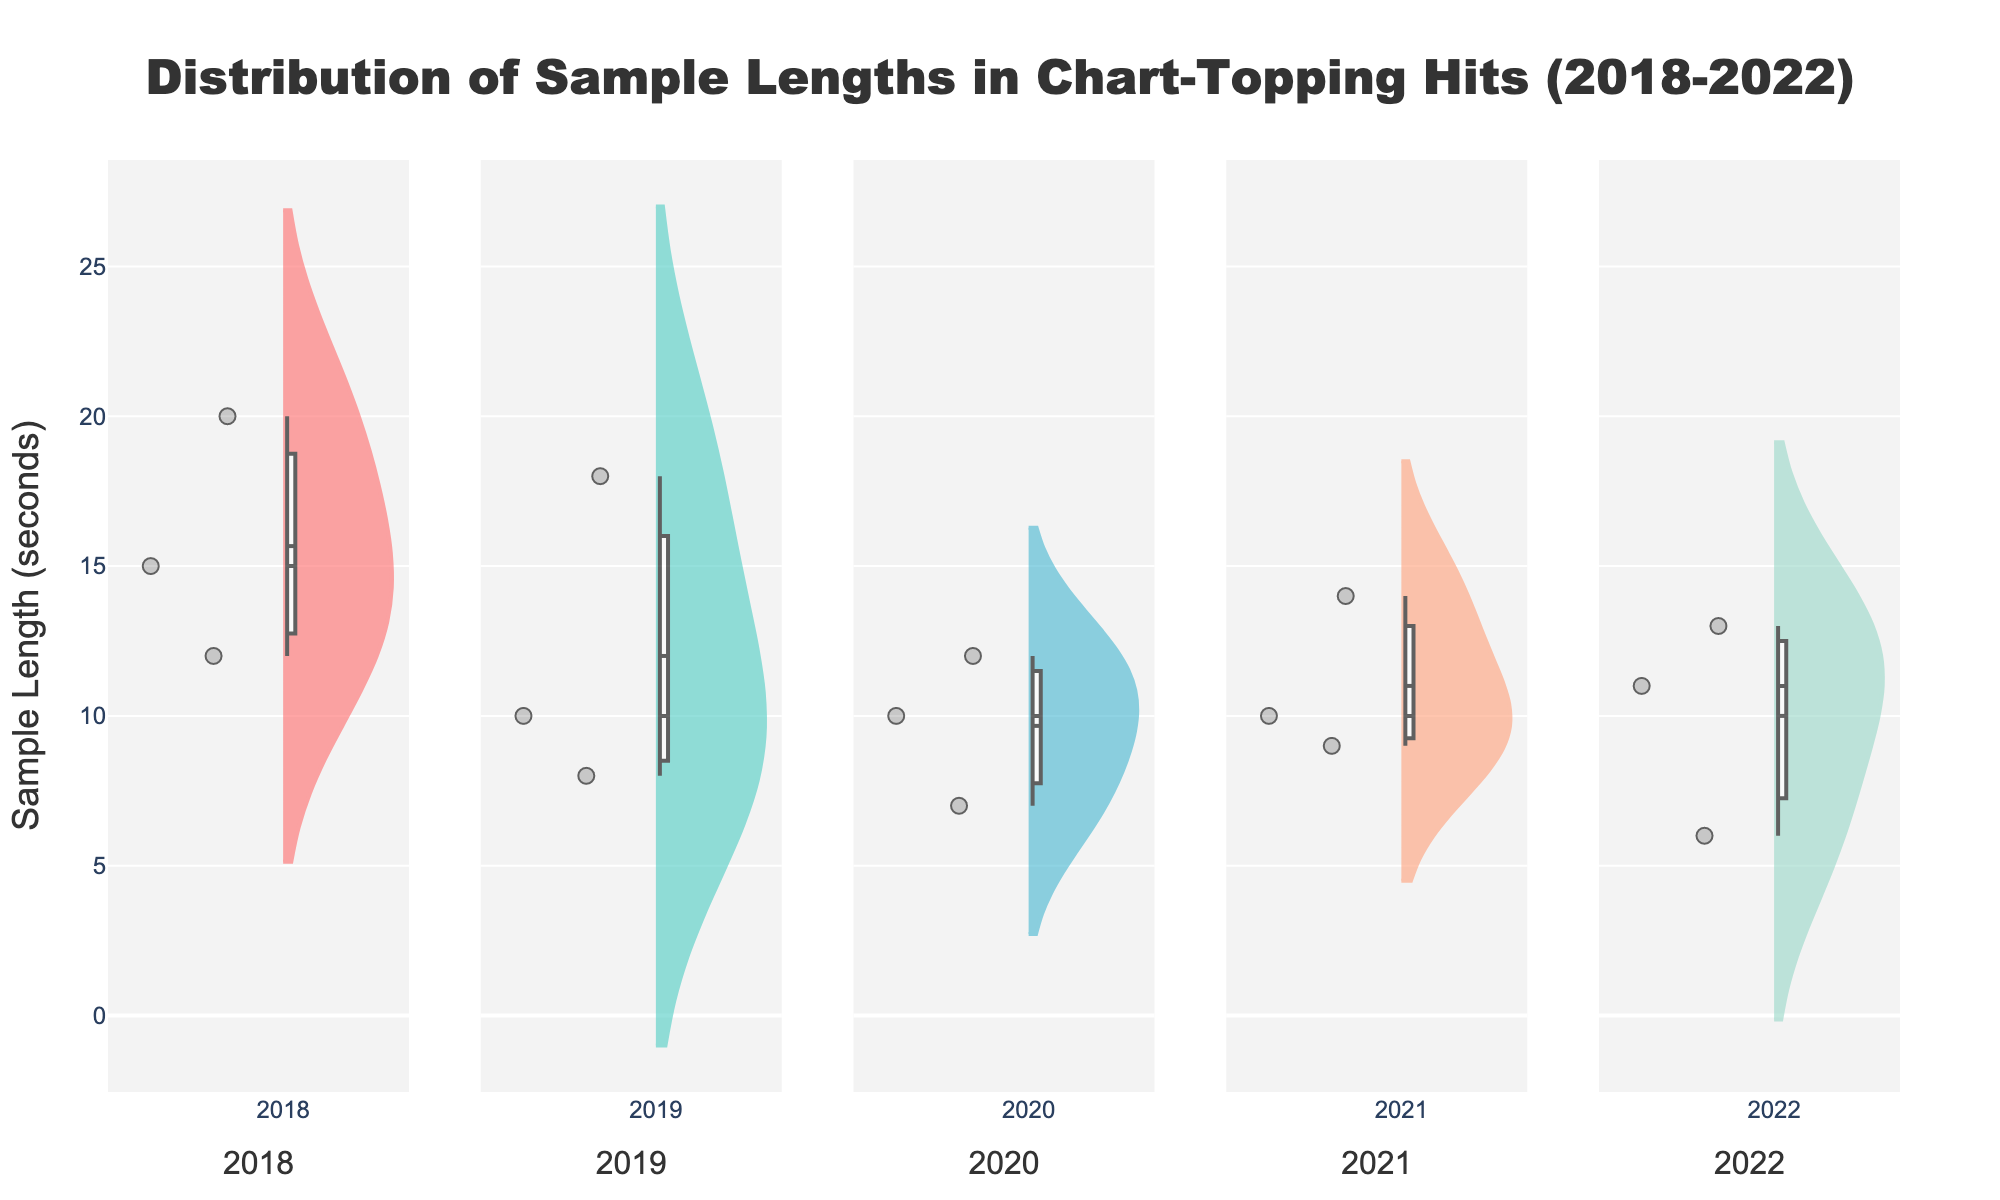What is the title of the figure? The title of the figure is located at the top and typically in a larger font. In this case, it reads "Distribution of Sample Lengths in Chart-Topping Hits (2018-2022)".
Answer: Distribution of Sample Lengths in Chart-Topping Hits (2018-2022) How many years of data are represented in the figure? By looking at the subplots, it is clear that each subplot represents a different year, and there are five subplots in total.
Answer: Five What is the range of sample lengths for songs in 2019? To find the range of sample lengths for 2019, locate the 2019 subplot and identify the minimum and maximum sample lengths. The minimum is 8 seconds, and the maximum is 18 seconds, so the range is 18 - 8.
Answer: 10 seconds Which year has the smallest median sample length? To determine the year with the smallest median sample length, locate the median lines within each violin plot. The 2022 violin plot has the median at 11 seconds, which is the smallest among all years.
Answer: 2022 Are there any outliers in the sample lengths for 2020? In violin plots, outliers typically appear as individual points outside the main distribution. The 2020 subplot does not show any points far from the distribution, indicating no outliers.
Answer: No What is the maximum sample length in 2018? To find the maximum sample length for 2018, look at the top of the violin plot for 2018. The highest point corresponds to 20 seconds.
Answer: 20 seconds Which year has the highest variability in sample lengths? Variability can be judged by the spread of the violin plot. The 2018 subplot has the widest spread, from 12 to 20 seconds, indicating the highest variability.
Answer: 2018 Compare the median sample lengths between 2019 and 2021. Which is greater? Observe the median lines in the 2019 and 2021 subplots. The median for 2019 is around 10 seconds, and for 2021 it is around 12 seconds. Therefore, 2021 has a greater median sample length.
Answer: 2021 What year has the most data points for sample lengths? By counting the number of individual points in each subplot, the year with the highest count is 2018, which has three data points showing sample lengths.
Answer: 2018 